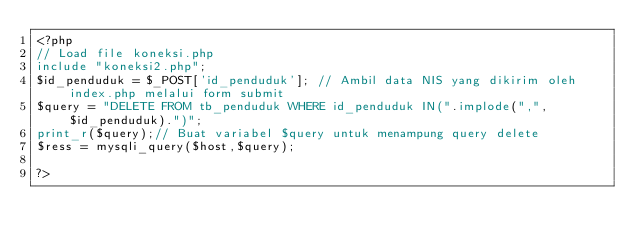Convert code to text. <code><loc_0><loc_0><loc_500><loc_500><_PHP_><?php
// Load file koneksi.php
include "koneksi2.php";
$id_penduduk = $_POST['id_penduduk']; // Ambil data NIS yang dikirim oleh index.php melalui form submit
$query = "DELETE FROM tb_penduduk WHERE id_penduduk IN(".implode(",", $id_penduduk).")";
print_r($query);// Buat variabel $query untuk menampung query delete
$ress = mysqli_query($host,$query);

?></code> 